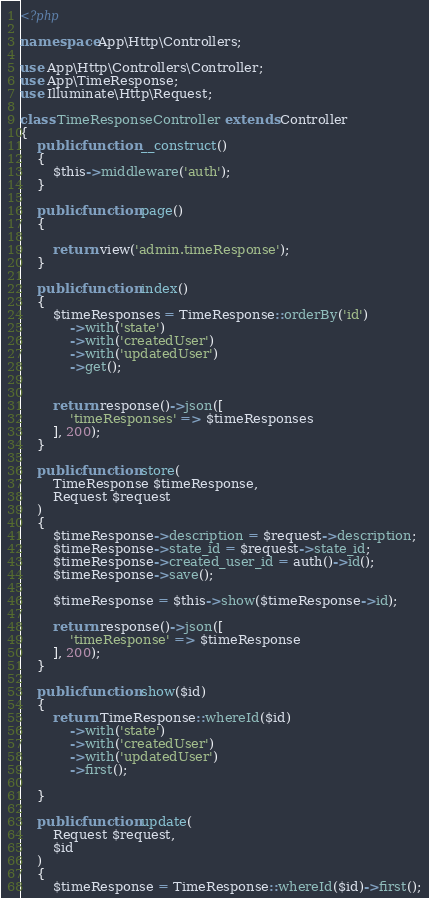Convert code to text. <code><loc_0><loc_0><loc_500><loc_500><_PHP_><?php

namespace App\Http\Controllers;

use App\Http\Controllers\Controller;
use App\TimeResponse;
use Illuminate\Http\Request;

class TimeResponseController extends Controller
{
    public function __construct()
    {
        $this->middleware('auth');
    }

    public function page()
    {

        return view('admin.timeResponse');
    }

    public function index()
    {
        $timeResponses = TimeResponse::orderBy('id')
            ->with('state')
            ->with('createdUser')
            ->with('updatedUser')
            ->get();


        return response()->json([
            'timeResponses' => $timeResponses
        ], 200);
    }

    public function store(
        TimeResponse $timeResponse,
        Request $request
    )
    {
        $timeResponse->description = $request->description;
        $timeResponse->state_id = $request->state_id;
        $timeResponse->created_user_id = auth()->id();
        $timeResponse->save();

        $timeResponse = $this->show($timeResponse->id);

        return response()->json([
            'timeResponse' => $timeResponse
        ], 200);
    }

    public function show($id)
    {
        return TimeResponse::whereId($id)
            ->with('state')
            ->with('createdUser')
            ->with('updatedUser')
            ->first();

    }

    public function update(
        Request $request,
        $id
    )
    {
        $timeResponse = TimeResponse::whereId($id)->first();</code> 